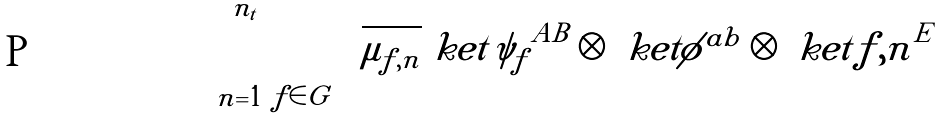<formula> <loc_0><loc_0><loc_500><loc_500>\sum _ { n = 1 } ^ { n _ { t } } \sum _ { f \in G } \sqrt { \mu _ { f , n } } \ k e t { \psi _ { f } } ^ { A B } \otimes \ k e t { \phi } ^ { a b } \otimes \ k e t { f , n } ^ { E }</formula> 